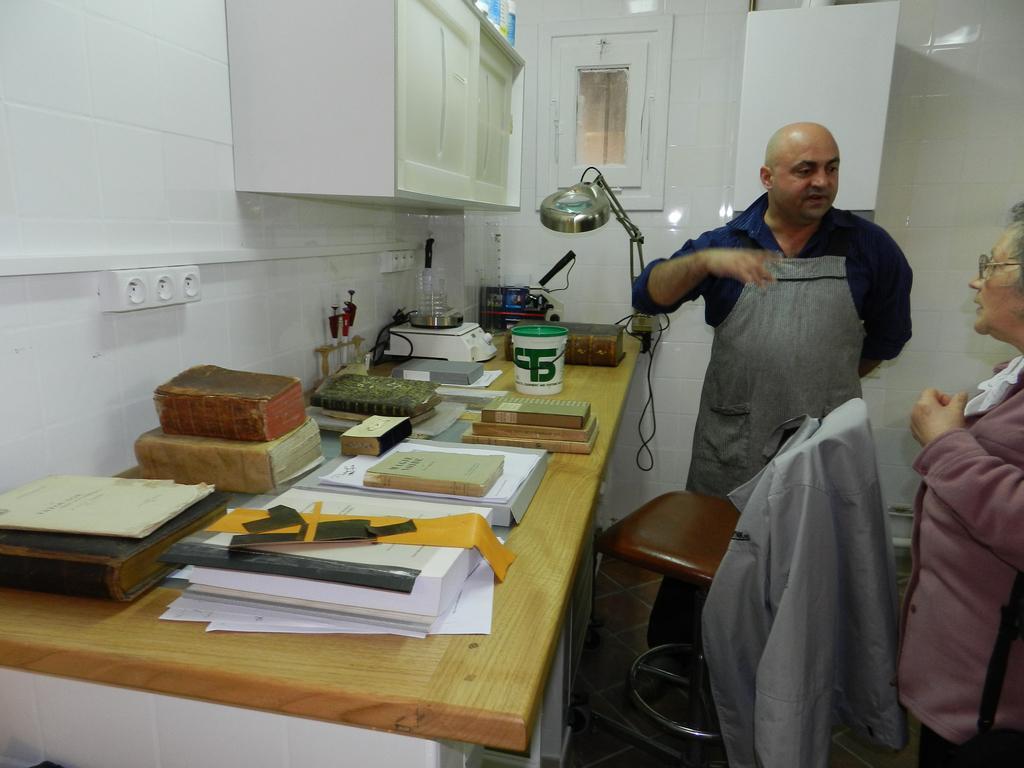Please provide a concise description of this image. In the right side a man is standing, talking. In the left side there are books. 